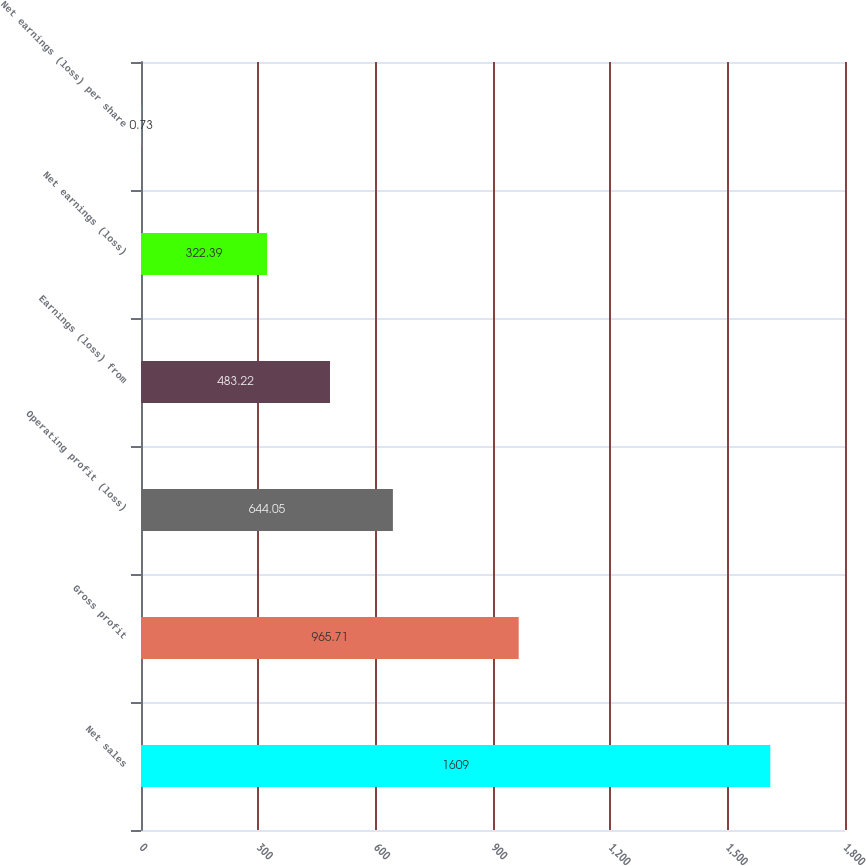Convert chart to OTSL. <chart><loc_0><loc_0><loc_500><loc_500><bar_chart><fcel>Net sales<fcel>Gross profit<fcel>Operating profit (loss)<fcel>Earnings (loss) from<fcel>Net earnings (loss)<fcel>Net earnings (loss) per share<nl><fcel>1609<fcel>965.71<fcel>644.05<fcel>483.22<fcel>322.39<fcel>0.73<nl></chart> 